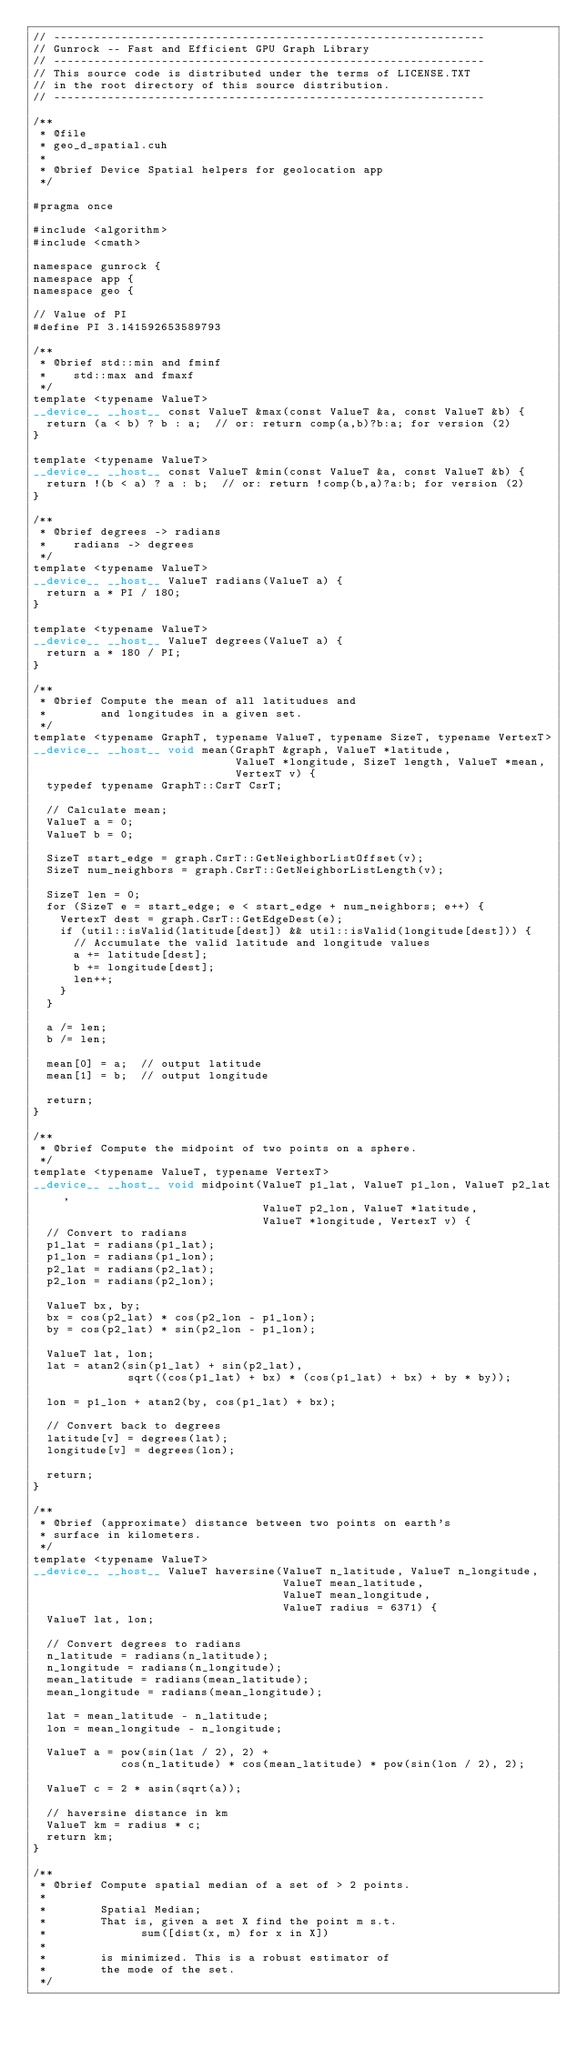Convert code to text. <code><loc_0><loc_0><loc_500><loc_500><_Cuda_>// ----------------------------------------------------------------
// Gunrock -- Fast and Efficient GPU Graph Library
// ----------------------------------------------------------------
// This source code is distributed under the terms of LICENSE.TXT
// in the root directory of this source distribution.
// ----------------------------------------------------------------

/**
 * @file
 * geo_d_spatial.cuh
 *
 * @brief Device Spatial helpers for geolocation app
 */

#pragma once

#include <algorithm>
#include <cmath>

namespace gunrock {
namespace app {
namespace geo {

// Value of PI
#define PI 3.141592653589793

/**
 * @brief std::min and fminf
 *	  std::max and fmaxf
 */
template <typename ValueT>
__device__ __host__ const ValueT &max(const ValueT &a, const ValueT &b) {
  return (a < b) ? b : a;  // or: return comp(a,b)?b:a; for version (2)
}

template <typename ValueT>
__device__ __host__ const ValueT &min(const ValueT &a, const ValueT &b) {
  return !(b < a) ? a : b;  // or: return !comp(b,a)?a:b; for version (2)
}

/**
 * @brief degrees -> radians
 *	  radians -> degrees
 */
template <typename ValueT>
__device__ __host__ ValueT radians(ValueT a) {
  return a * PI / 180;
}

template <typename ValueT>
__device__ __host__ ValueT degrees(ValueT a) {
  return a * 180 / PI;
}

/**
 * @brief Compute the mean of all latitudues and
 *        and longitudes in a given set.
 */
template <typename GraphT, typename ValueT, typename SizeT, typename VertexT>
__device__ __host__ void mean(GraphT &graph, ValueT *latitude,
                              ValueT *longitude, SizeT length, ValueT *mean,
                              VertexT v) {
  typedef typename GraphT::CsrT CsrT;

  // Calculate mean;
  ValueT a = 0;
  ValueT b = 0;

  SizeT start_edge = graph.CsrT::GetNeighborListOffset(v);
  SizeT num_neighbors = graph.CsrT::GetNeighborListLength(v);

  SizeT len = 0;
  for (SizeT e = start_edge; e < start_edge + num_neighbors; e++) {
    VertexT dest = graph.CsrT::GetEdgeDest(e);
    if (util::isValid(latitude[dest]) && util::isValid(longitude[dest])) {
      // Accumulate the valid latitude and longitude values
      a += latitude[dest];
      b += longitude[dest];
      len++;
    }
  }

  a /= len;
  b /= len;

  mean[0] = a;  // output latitude
  mean[1] = b;  // output longitude

  return;
}

/**
 * @brief Compute the midpoint of two points on a sphere.
 */
template <typename ValueT, typename VertexT>
__device__ __host__ void midpoint(ValueT p1_lat, ValueT p1_lon, ValueT p2_lat,
                                  ValueT p2_lon, ValueT *latitude,
                                  ValueT *longitude, VertexT v) {
  // Convert to radians
  p1_lat = radians(p1_lat);
  p1_lon = radians(p1_lon);
  p2_lat = radians(p2_lat);
  p2_lon = radians(p2_lon);

  ValueT bx, by;
  bx = cos(p2_lat) * cos(p2_lon - p1_lon);
  by = cos(p2_lat) * sin(p2_lon - p1_lon);

  ValueT lat, lon;
  lat = atan2(sin(p1_lat) + sin(p2_lat),
              sqrt((cos(p1_lat) + bx) * (cos(p1_lat) + bx) + by * by));

  lon = p1_lon + atan2(by, cos(p1_lat) + bx);

  // Convert back to degrees
  latitude[v] = degrees(lat);
  longitude[v] = degrees(lon);

  return;
}

/**
 * @brief (approximate) distance between two points on earth's
 * surface in kilometers.
 */
template <typename ValueT>
__device__ __host__ ValueT haversine(ValueT n_latitude, ValueT n_longitude,
                                     ValueT mean_latitude,
                                     ValueT mean_longitude,
                                     ValueT radius = 6371) {
  ValueT lat, lon;

  // Convert degrees to radians
  n_latitude = radians(n_latitude);
  n_longitude = radians(n_longitude);
  mean_latitude = radians(mean_latitude);
  mean_longitude = radians(mean_longitude);

  lat = mean_latitude - n_latitude;
  lon = mean_longitude - n_longitude;

  ValueT a = pow(sin(lat / 2), 2) +
             cos(n_latitude) * cos(mean_latitude) * pow(sin(lon / 2), 2);

  ValueT c = 2 * asin(sqrt(a));

  // haversine distance in km
  ValueT km = radius * c;
  return km;
}

/**
 * @brief Compute spatial median of a set of > 2 points.
 *
 *        Spatial Median;
 *        That is, given a set X find the point m s.t.
 *              sum([dist(x, m) for x in X])
 *
 *        is minimized. This is a robust estimator of
 *        the mode of the set.
 */</code> 